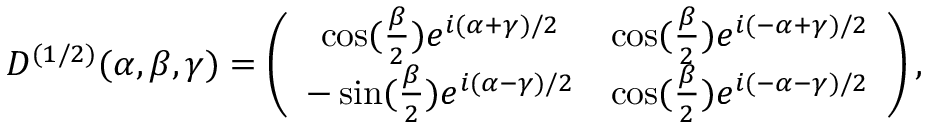Convert formula to latex. <formula><loc_0><loc_0><loc_500><loc_500>D ^ { ( 1 / 2 ) } ( \alpha , \beta , \gamma ) = \left ( \begin{array} { c c } { { \cos ( \frac { \beta } { 2 } ) e ^ { i ( \alpha + \gamma ) / 2 } } } & { { \cos ( \frac { \beta } { 2 } ) e ^ { i ( - \alpha + \gamma ) / 2 } } } \\ { { - \sin ( \frac { \beta } { 2 } ) e ^ { i ( \alpha - \gamma ) / 2 } } } & { { \cos ( \frac { \beta } { 2 } ) e ^ { i ( - \alpha - \gamma ) / 2 } } } \end{array} \right ) ,</formula> 